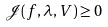Convert formula to latex. <formula><loc_0><loc_0><loc_500><loc_500>\mathcal { J } ( f , \lambda , V ) \geq 0</formula> 